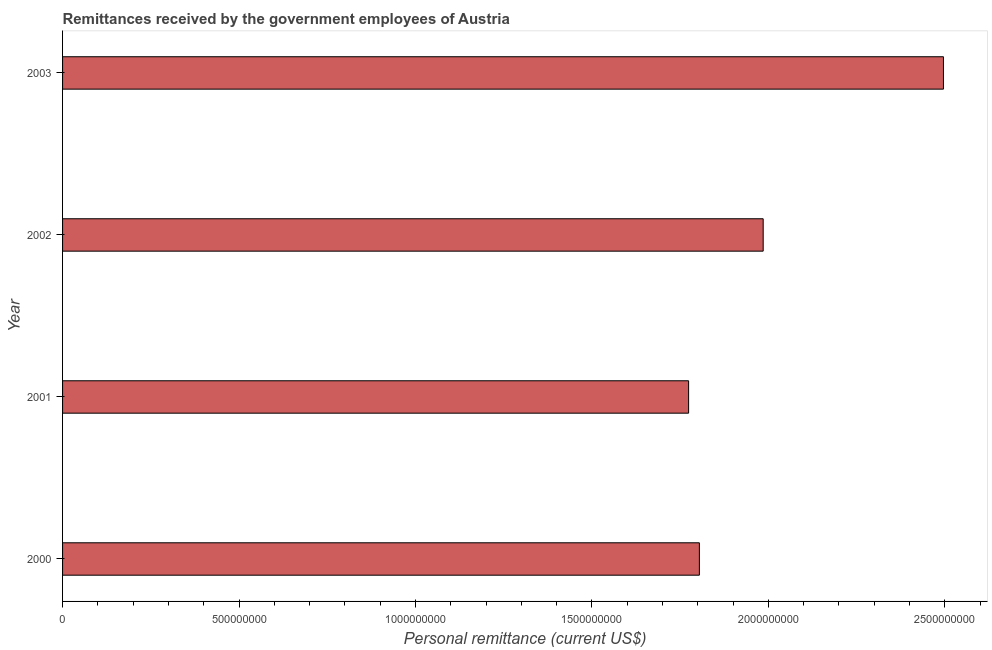Does the graph contain grids?
Your response must be concise. No. What is the title of the graph?
Provide a succinct answer. Remittances received by the government employees of Austria. What is the label or title of the X-axis?
Keep it short and to the point. Personal remittance (current US$). What is the label or title of the Y-axis?
Give a very brief answer. Year. What is the personal remittances in 2001?
Provide a succinct answer. 1.77e+09. Across all years, what is the maximum personal remittances?
Your response must be concise. 2.50e+09. Across all years, what is the minimum personal remittances?
Make the answer very short. 1.77e+09. What is the sum of the personal remittances?
Your response must be concise. 8.06e+09. What is the difference between the personal remittances in 2002 and 2003?
Give a very brief answer. -5.11e+08. What is the average personal remittances per year?
Your answer should be very brief. 2.01e+09. What is the median personal remittances?
Provide a succinct answer. 1.89e+09. In how many years, is the personal remittances greater than 500000000 US$?
Make the answer very short. 4. What is the ratio of the personal remittances in 2001 to that in 2003?
Keep it short and to the point. 0.71. What is the difference between the highest and the second highest personal remittances?
Give a very brief answer. 5.11e+08. What is the difference between the highest and the lowest personal remittances?
Offer a very short reply. 7.22e+08. In how many years, is the personal remittances greater than the average personal remittances taken over all years?
Offer a terse response. 1. What is the difference between two consecutive major ticks on the X-axis?
Keep it short and to the point. 5.00e+08. What is the Personal remittance (current US$) in 2000?
Offer a terse response. 1.80e+09. What is the Personal remittance (current US$) in 2001?
Offer a very short reply. 1.77e+09. What is the Personal remittance (current US$) in 2002?
Your response must be concise. 1.99e+09. What is the Personal remittance (current US$) in 2003?
Keep it short and to the point. 2.50e+09. What is the difference between the Personal remittance (current US$) in 2000 and 2001?
Give a very brief answer. 3.05e+07. What is the difference between the Personal remittance (current US$) in 2000 and 2002?
Provide a short and direct response. -1.81e+08. What is the difference between the Personal remittance (current US$) in 2000 and 2003?
Make the answer very short. -6.92e+08. What is the difference between the Personal remittance (current US$) in 2001 and 2002?
Provide a short and direct response. -2.11e+08. What is the difference between the Personal remittance (current US$) in 2001 and 2003?
Keep it short and to the point. -7.22e+08. What is the difference between the Personal remittance (current US$) in 2002 and 2003?
Your answer should be very brief. -5.11e+08. What is the ratio of the Personal remittance (current US$) in 2000 to that in 2001?
Provide a succinct answer. 1.02. What is the ratio of the Personal remittance (current US$) in 2000 to that in 2002?
Provide a succinct answer. 0.91. What is the ratio of the Personal remittance (current US$) in 2000 to that in 2003?
Make the answer very short. 0.72. What is the ratio of the Personal remittance (current US$) in 2001 to that in 2002?
Give a very brief answer. 0.89. What is the ratio of the Personal remittance (current US$) in 2001 to that in 2003?
Your answer should be very brief. 0.71. What is the ratio of the Personal remittance (current US$) in 2002 to that in 2003?
Offer a terse response. 0.8. 